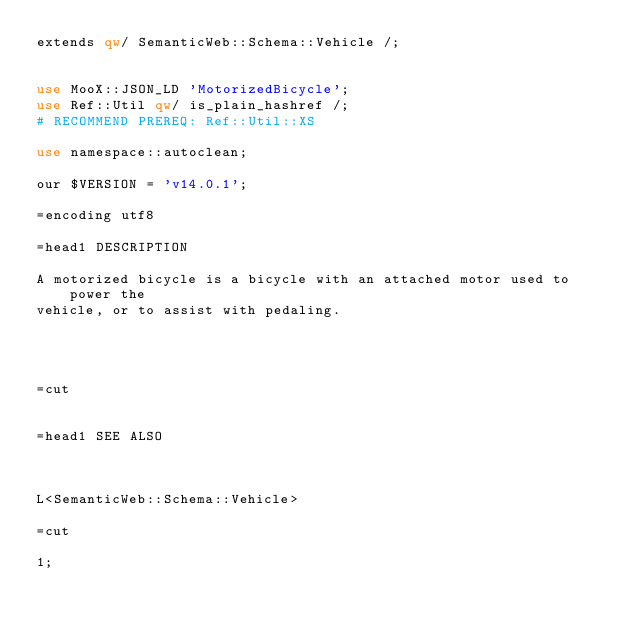<code> <loc_0><loc_0><loc_500><loc_500><_Perl_>extends qw/ SemanticWeb::Schema::Vehicle /;


use MooX::JSON_LD 'MotorizedBicycle';
use Ref::Util qw/ is_plain_hashref /;
# RECOMMEND PREREQ: Ref::Util::XS

use namespace::autoclean;

our $VERSION = 'v14.0.1';

=encoding utf8

=head1 DESCRIPTION

A motorized bicycle is a bicycle with an attached motor used to power the
vehicle, or to assist with pedaling.




=cut


=head1 SEE ALSO



L<SemanticWeb::Schema::Vehicle>

=cut

1;
</code> 